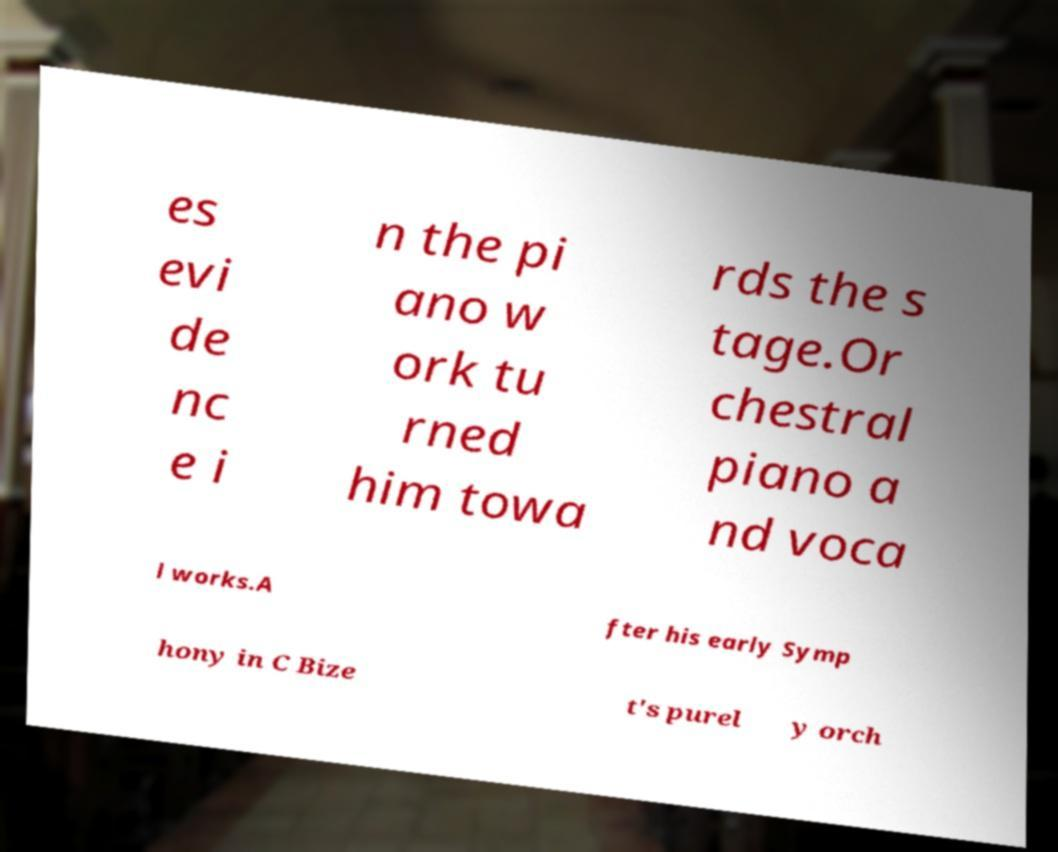Can you accurately transcribe the text from the provided image for me? es evi de nc e i n the pi ano w ork tu rned him towa rds the s tage.Or chestral piano a nd voca l works.A fter his early Symp hony in C Bize t's purel y orch 